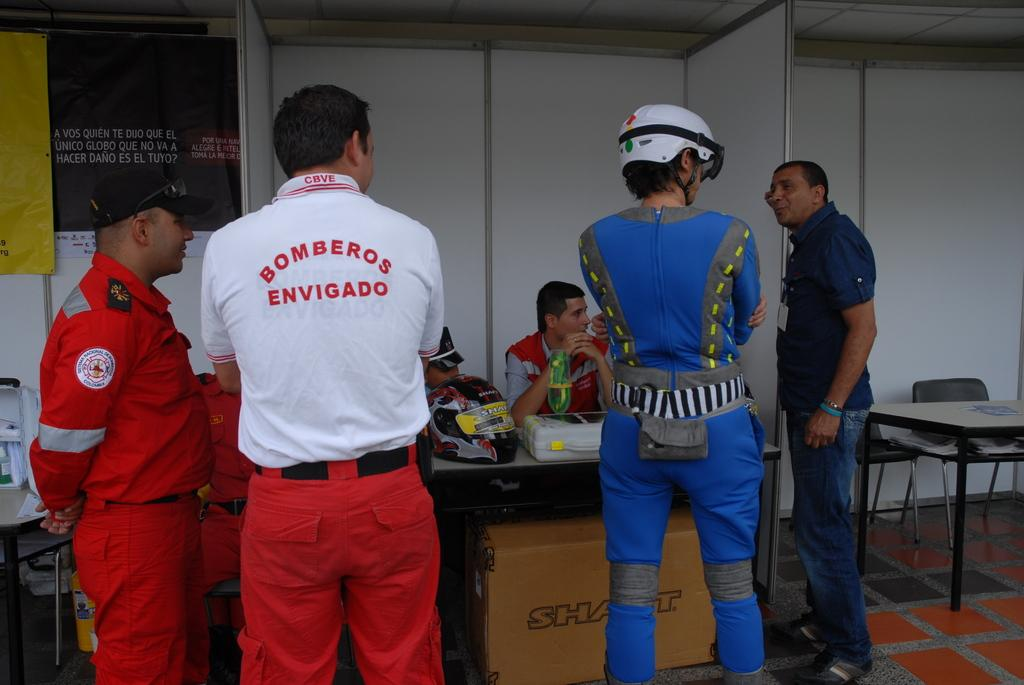<image>
Relay a brief, clear account of the picture shown. A man wearing red pants and a white shirt with Bomberos Envigado on the back is standing with his arms crossed. 